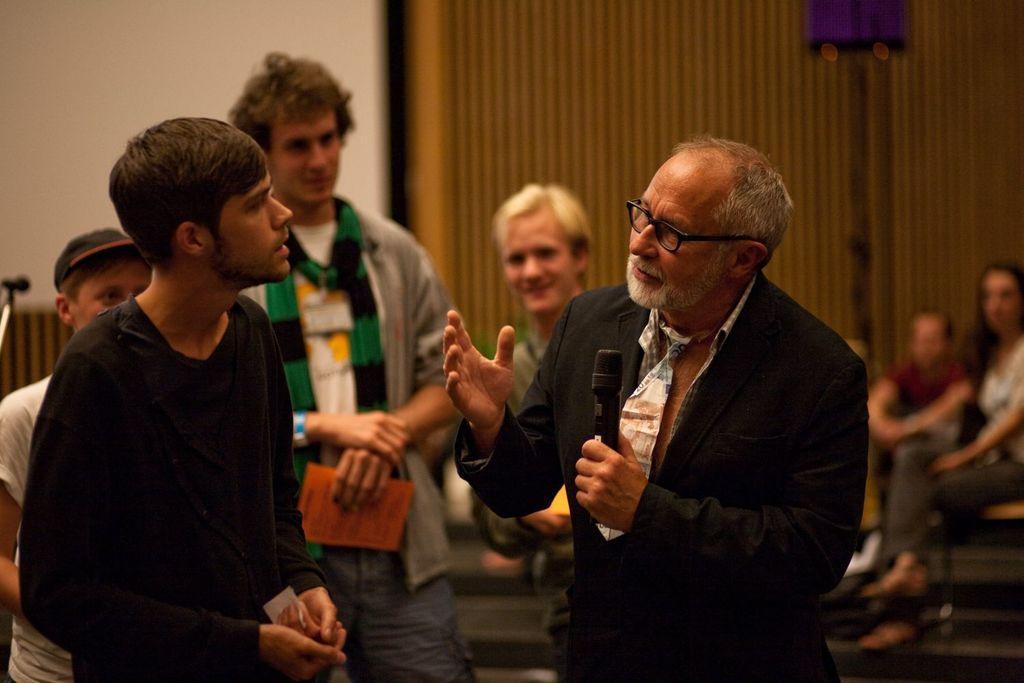How would you summarize this image in a sentence or two? In this image I can see group of people standing. In front the person is holding the microphone. In the background the wall is in white color. 